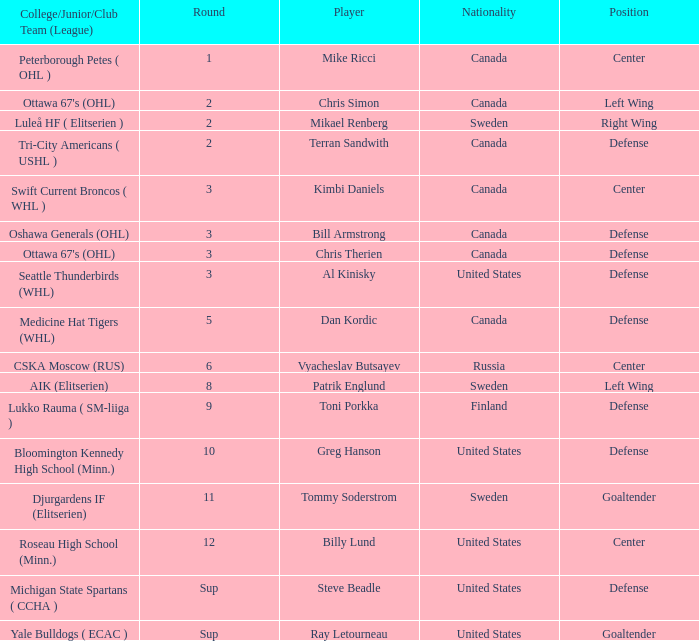What player is playing on round 1 Mike Ricci. 